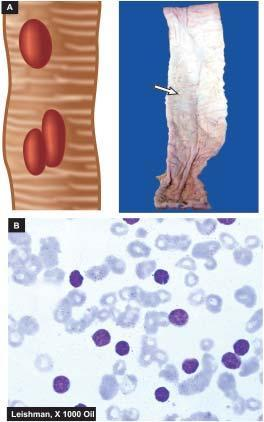do typhoid ulcers in the small intestine appear characteristically oval with their long axis parallel to the long axis of the bowel?
Answer the question using a single word or phrase. Yes 